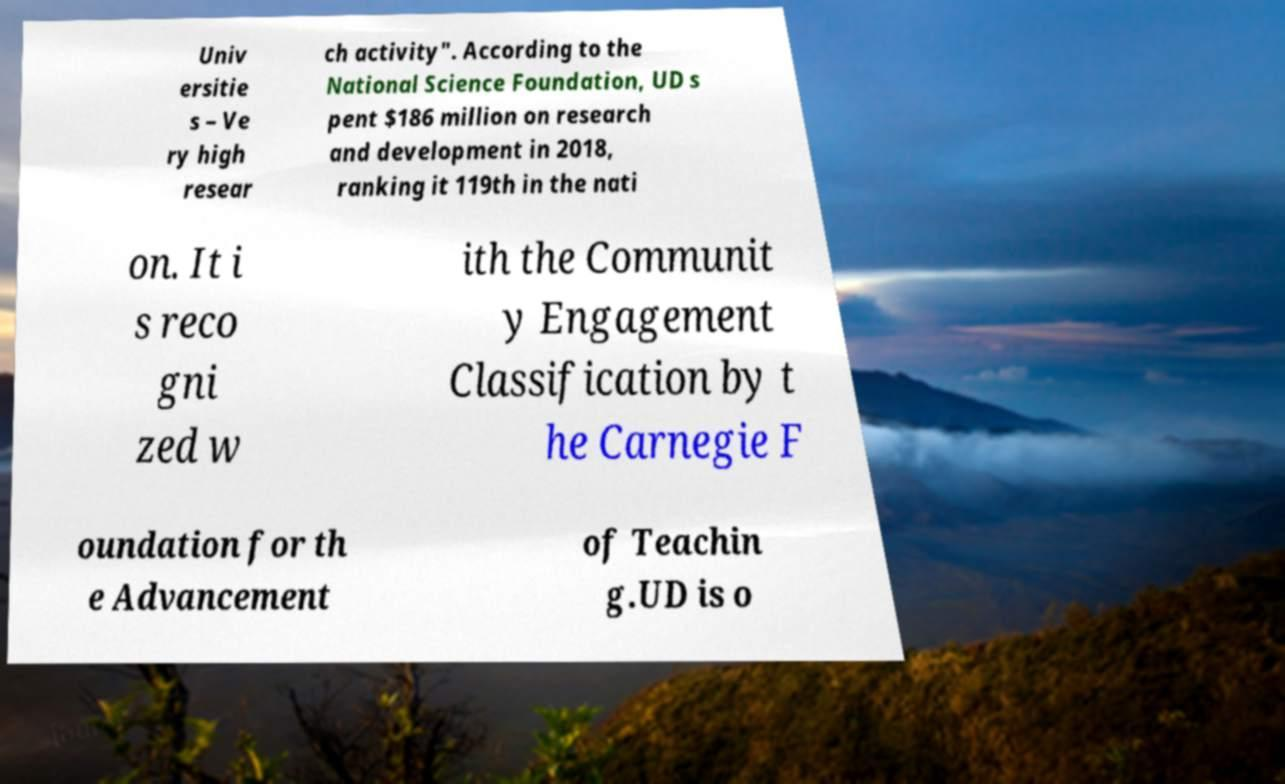Please read and relay the text visible in this image. What does it say? Univ ersitie s – Ve ry high resear ch activity". According to the National Science Foundation, UD s pent $186 million on research and development in 2018, ranking it 119th in the nati on. It i s reco gni zed w ith the Communit y Engagement Classification by t he Carnegie F oundation for th e Advancement of Teachin g.UD is o 